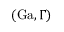<formula> <loc_0><loc_0><loc_500><loc_500>( G a , \Gamma )</formula> 